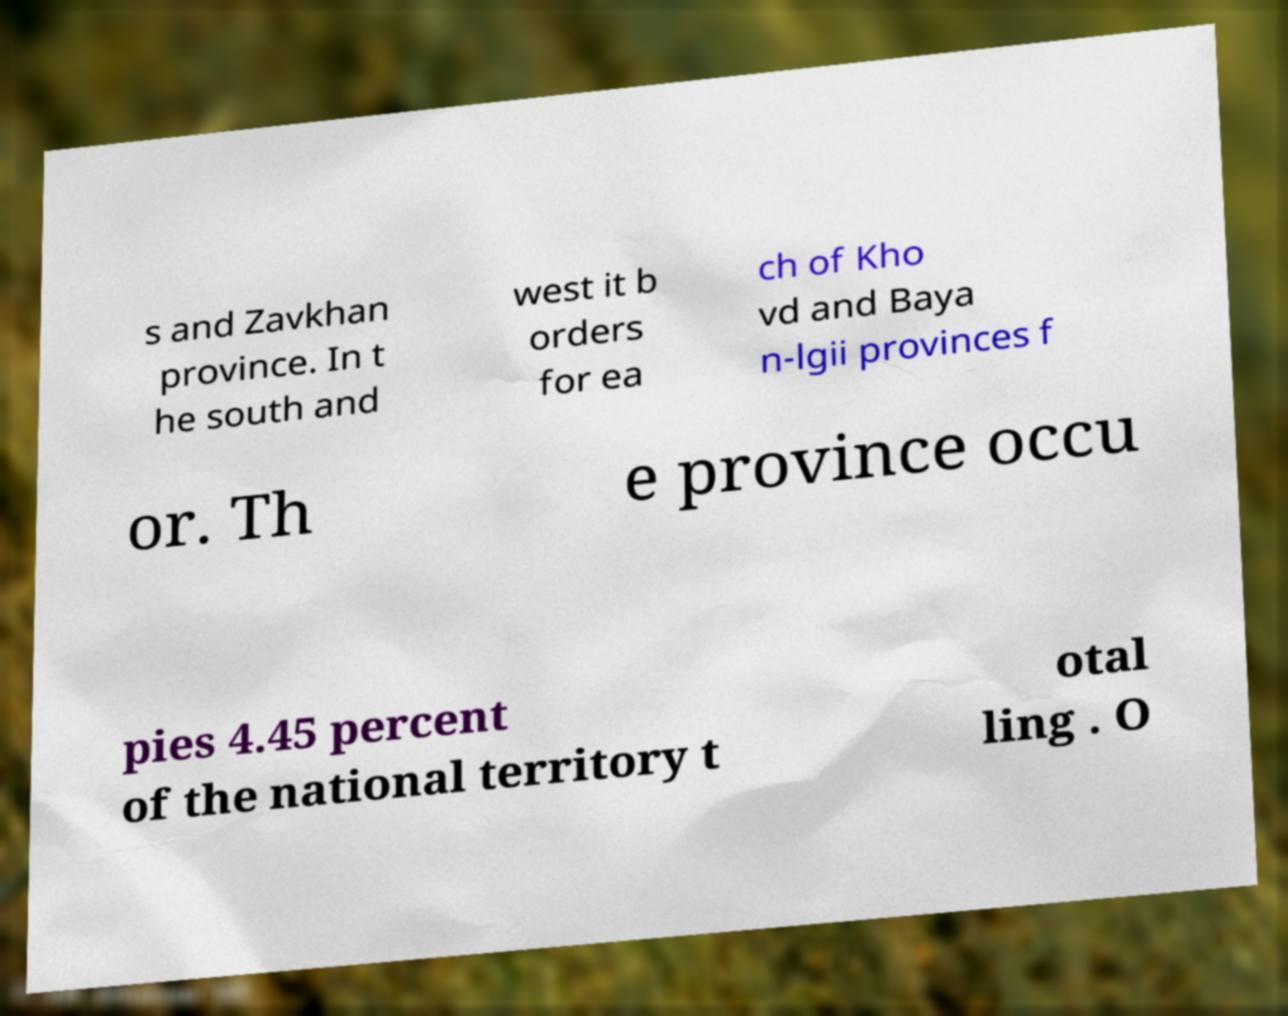What messages or text are displayed in this image? I need them in a readable, typed format. s and Zavkhan province. In t he south and west it b orders for ea ch of Kho vd and Baya n-lgii provinces f or. Th e province occu pies 4.45 percent of the national territory t otal ling . O 